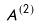<formula> <loc_0><loc_0><loc_500><loc_500>A ^ { ( 2 ) }</formula> 